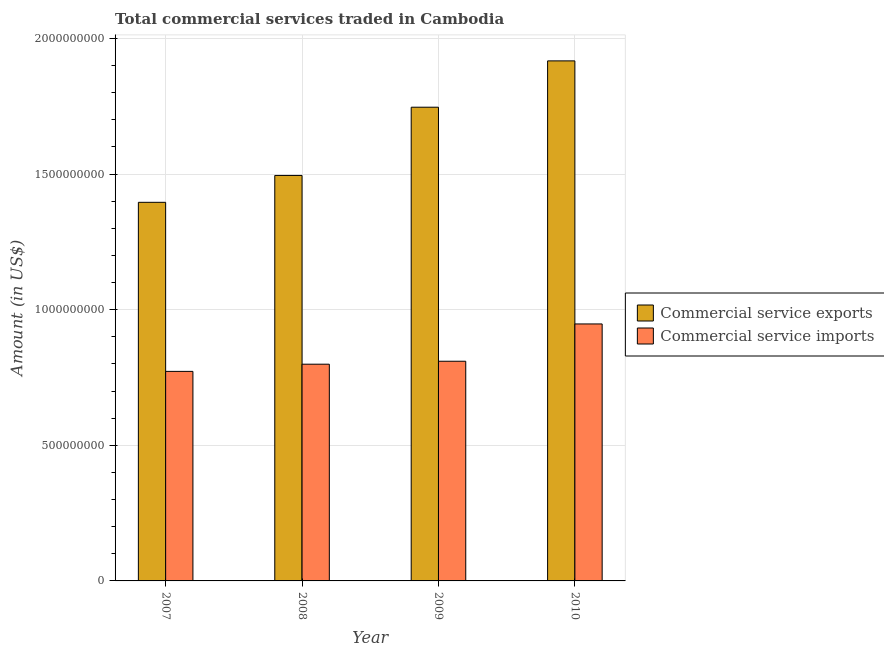How many groups of bars are there?
Make the answer very short. 4. Are the number of bars per tick equal to the number of legend labels?
Make the answer very short. Yes. Are the number of bars on each tick of the X-axis equal?
Offer a very short reply. Yes. How many bars are there on the 3rd tick from the left?
Give a very brief answer. 2. What is the label of the 1st group of bars from the left?
Make the answer very short. 2007. What is the amount of commercial service imports in 2009?
Keep it short and to the point. 8.10e+08. Across all years, what is the maximum amount of commercial service imports?
Your response must be concise. 9.47e+08. Across all years, what is the minimum amount of commercial service imports?
Give a very brief answer. 7.72e+08. In which year was the amount of commercial service exports minimum?
Give a very brief answer. 2007. What is the total amount of commercial service exports in the graph?
Offer a terse response. 6.55e+09. What is the difference between the amount of commercial service exports in 2007 and that in 2008?
Offer a very short reply. -9.91e+07. What is the difference between the amount of commercial service imports in 2010 and the amount of commercial service exports in 2009?
Offer a very short reply. 1.38e+08. What is the average amount of commercial service exports per year?
Your answer should be compact. 1.64e+09. In how many years, is the amount of commercial service exports greater than 400000000 US$?
Provide a short and direct response. 4. What is the ratio of the amount of commercial service imports in 2007 to that in 2010?
Your answer should be compact. 0.82. Is the difference between the amount of commercial service exports in 2007 and 2010 greater than the difference between the amount of commercial service imports in 2007 and 2010?
Keep it short and to the point. No. What is the difference between the highest and the second highest amount of commercial service imports?
Ensure brevity in your answer.  1.38e+08. What is the difference between the highest and the lowest amount of commercial service imports?
Your answer should be compact. 1.75e+08. What does the 1st bar from the left in 2008 represents?
Make the answer very short. Commercial service exports. What does the 1st bar from the right in 2010 represents?
Your answer should be compact. Commercial service imports. How many years are there in the graph?
Your answer should be very brief. 4. What is the difference between two consecutive major ticks on the Y-axis?
Provide a short and direct response. 5.00e+08. Are the values on the major ticks of Y-axis written in scientific E-notation?
Your answer should be compact. No. How many legend labels are there?
Provide a short and direct response. 2. What is the title of the graph?
Your answer should be very brief. Total commercial services traded in Cambodia. What is the label or title of the X-axis?
Your response must be concise. Year. What is the Amount (in US$) of Commercial service exports in 2007?
Give a very brief answer. 1.40e+09. What is the Amount (in US$) of Commercial service imports in 2007?
Your answer should be very brief. 7.72e+08. What is the Amount (in US$) of Commercial service exports in 2008?
Give a very brief answer. 1.49e+09. What is the Amount (in US$) of Commercial service imports in 2008?
Provide a short and direct response. 7.99e+08. What is the Amount (in US$) of Commercial service exports in 2009?
Your answer should be very brief. 1.75e+09. What is the Amount (in US$) of Commercial service imports in 2009?
Keep it short and to the point. 8.10e+08. What is the Amount (in US$) in Commercial service exports in 2010?
Provide a short and direct response. 1.92e+09. What is the Amount (in US$) of Commercial service imports in 2010?
Your answer should be very brief. 9.47e+08. Across all years, what is the maximum Amount (in US$) in Commercial service exports?
Offer a terse response. 1.92e+09. Across all years, what is the maximum Amount (in US$) in Commercial service imports?
Give a very brief answer. 9.47e+08. Across all years, what is the minimum Amount (in US$) in Commercial service exports?
Give a very brief answer. 1.40e+09. Across all years, what is the minimum Amount (in US$) in Commercial service imports?
Keep it short and to the point. 7.72e+08. What is the total Amount (in US$) of Commercial service exports in the graph?
Offer a very short reply. 6.55e+09. What is the total Amount (in US$) of Commercial service imports in the graph?
Provide a succinct answer. 3.33e+09. What is the difference between the Amount (in US$) in Commercial service exports in 2007 and that in 2008?
Provide a short and direct response. -9.91e+07. What is the difference between the Amount (in US$) of Commercial service imports in 2007 and that in 2008?
Provide a succinct answer. -2.65e+07. What is the difference between the Amount (in US$) of Commercial service exports in 2007 and that in 2009?
Ensure brevity in your answer.  -3.51e+08. What is the difference between the Amount (in US$) of Commercial service imports in 2007 and that in 2009?
Provide a short and direct response. -3.74e+07. What is the difference between the Amount (in US$) in Commercial service exports in 2007 and that in 2010?
Offer a very short reply. -5.21e+08. What is the difference between the Amount (in US$) in Commercial service imports in 2007 and that in 2010?
Keep it short and to the point. -1.75e+08. What is the difference between the Amount (in US$) in Commercial service exports in 2008 and that in 2009?
Your answer should be very brief. -2.52e+08. What is the difference between the Amount (in US$) in Commercial service imports in 2008 and that in 2009?
Offer a terse response. -1.09e+07. What is the difference between the Amount (in US$) of Commercial service exports in 2008 and that in 2010?
Your response must be concise. -4.22e+08. What is the difference between the Amount (in US$) in Commercial service imports in 2008 and that in 2010?
Keep it short and to the point. -1.48e+08. What is the difference between the Amount (in US$) of Commercial service exports in 2009 and that in 2010?
Offer a very short reply. -1.71e+08. What is the difference between the Amount (in US$) of Commercial service imports in 2009 and that in 2010?
Keep it short and to the point. -1.38e+08. What is the difference between the Amount (in US$) in Commercial service exports in 2007 and the Amount (in US$) in Commercial service imports in 2008?
Offer a very short reply. 5.97e+08. What is the difference between the Amount (in US$) in Commercial service exports in 2007 and the Amount (in US$) in Commercial service imports in 2009?
Ensure brevity in your answer.  5.86e+08. What is the difference between the Amount (in US$) in Commercial service exports in 2007 and the Amount (in US$) in Commercial service imports in 2010?
Offer a terse response. 4.48e+08. What is the difference between the Amount (in US$) of Commercial service exports in 2008 and the Amount (in US$) of Commercial service imports in 2009?
Give a very brief answer. 6.85e+08. What is the difference between the Amount (in US$) in Commercial service exports in 2008 and the Amount (in US$) in Commercial service imports in 2010?
Provide a succinct answer. 5.47e+08. What is the difference between the Amount (in US$) of Commercial service exports in 2009 and the Amount (in US$) of Commercial service imports in 2010?
Offer a very short reply. 7.99e+08. What is the average Amount (in US$) of Commercial service exports per year?
Provide a succinct answer. 1.64e+09. What is the average Amount (in US$) of Commercial service imports per year?
Ensure brevity in your answer.  8.32e+08. In the year 2007, what is the difference between the Amount (in US$) in Commercial service exports and Amount (in US$) in Commercial service imports?
Offer a terse response. 6.23e+08. In the year 2008, what is the difference between the Amount (in US$) of Commercial service exports and Amount (in US$) of Commercial service imports?
Make the answer very short. 6.96e+08. In the year 2009, what is the difference between the Amount (in US$) in Commercial service exports and Amount (in US$) in Commercial service imports?
Keep it short and to the point. 9.37e+08. In the year 2010, what is the difference between the Amount (in US$) in Commercial service exports and Amount (in US$) in Commercial service imports?
Your response must be concise. 9.70e+08. What is the ratio of the Amount (in US$) of Commercial service exports in 2007 to that in 2008?
Make the answer very short. 0.93. What is the ratio of the Amount (in US$) of Commercial service imports in 2007 to that in 2008?
Give a very brief answer. 0.97. What is the ratio of the Amount (in US$) of Commercial service exports in 2007 to that in 2009?
Make the answer very short. 0.8. What is the ratio of the Amount (in US$) in Commercial service imports in 2007 to that in 2009?
Provide a short and direct response. 0.95. What is the ratio of the Amount (in US$) of Commercial service exports in 2007 to that in 2010?
Ensure brevity in your answer.  0.73. What is the ratio of the Amount (in US$) in Commercial service imports in 2007 to that in 2010?
Offer a terse response. 0.82. What is the ratio of the Amount (in US$) of Commercial service exports in 2008 to that in 2009?
Offer a terse response. 0.86. What is the ratio of the Amount (in US$) in Commercial service imports in 2008 to that in 2009?
Make the answer very short. 0.99. What is the ratio of the Amount (in US$) in Commercial service exports in 2008 to that in 2010?
Provide a succinct answer. 0.78. What is the ratio of the Amount (in US$) of Commercial service imports in 2008 to that in 2010?
Give a very brief answer. 0.84. What is the ratio of the Amount (in US$) of Commercial service exports in 2009 to that in 2010?
Provide a succinct answer. 0.91. What is the ratio of the Amount (in US$) in Commercial service imports in 2009 to that in 2010?
Offer a terse response. 0.85. What is the difference between the highest and the second highest Amount (in US$) of Commercial service exports?
Ensure brevity in your answer.  1.71e+08. What is the difference between the highest and the second highest Amount (in US$) of Commercial service imports?
Your answer should be compact. 1.38e+08. What is the difference between the highest and the lowest Amount (in US$) in Commercial service exports?
Make the answer very short. 5.21e+08. What is the difference between the highest and the lowest Amount (in US$) of Commercial service imports?
Offer a very short reply. 1.75e+08. 